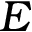<formula> <loc_0><loc_0><loc_500><loc_500>E</formula> 